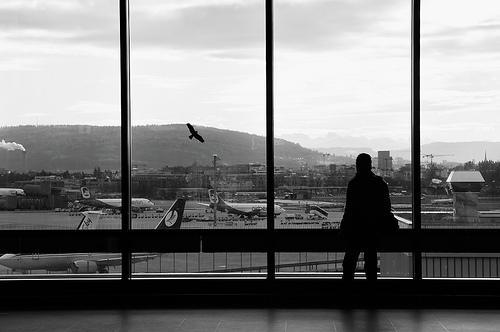What two objects shown can fly?
Short answer required. Bird and plane. How many people are by the window?
Concise answer only. 1. What companies plane is in the window?
Keep it brief. Sky. What is flying?
Quick response, please. Bird. Is the person looking at the bird or the planes?
Short answer required. Bird. 